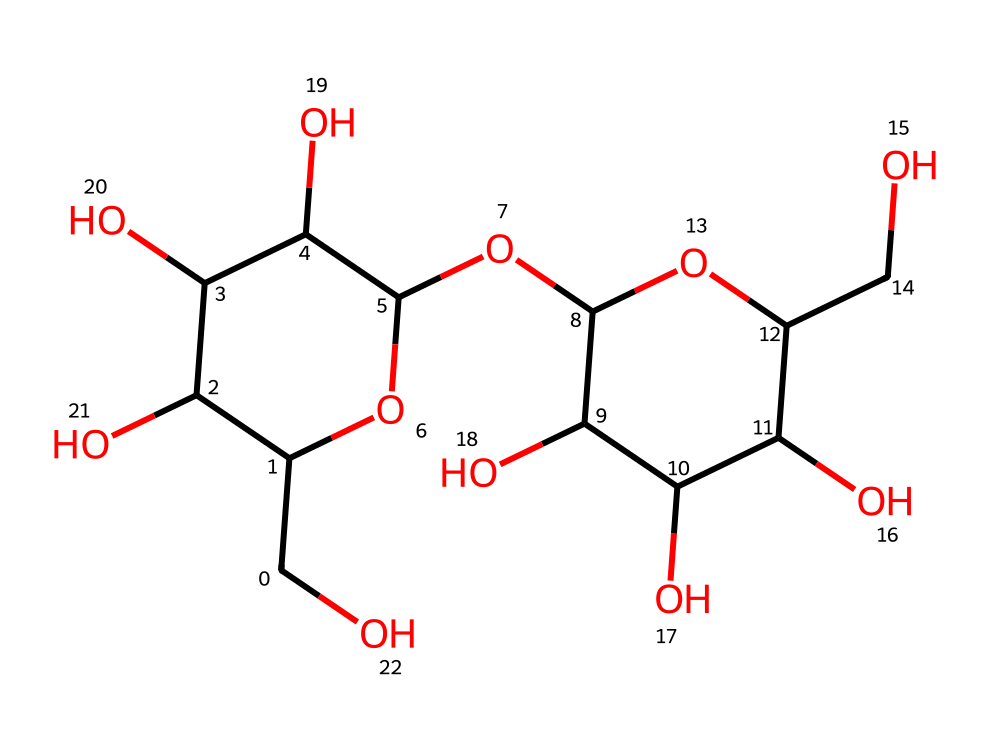What is the main structural type of this chemical? This chemical is composed of multiple sugar units connected by glycosidic bonds, indicating it is a polysaccharide. This structure supports its classification as a carbohydrate.
Answer: polysaccharide How many oxygen atoms are present in the structure? By analyzing the structure, we can count the oxygen atoms depicted in the molecular framework, which total up to 8.
Answer: 8 What is the primary function of glycogen in the body? Glycogen primarily serves as a storage form of glucose, providing energy for muscle metabolism, especially in activities like physical exercise.
Answer: energy storage How many carbon atoms are in this chemical structure? By inspecting each part of the molecule, we can count a total of 24 carbon atoms based on the structural components outlined in the SMILES representation.
Answer: 24 What type of bond links the sugar units in this molecule? The sugar units are linked by glycosidic bonds, which are specifically formed between the hydroxyl groups of the sugar molecules through a dehydration reaction.
Answer: glycosidic bonds What role does glycogen play in muscle building? Glycogen serves as a quick energy source for muscle contractions during physical activities, supporting muscle performance and recovery in athletes.
Answer: quick energy source 